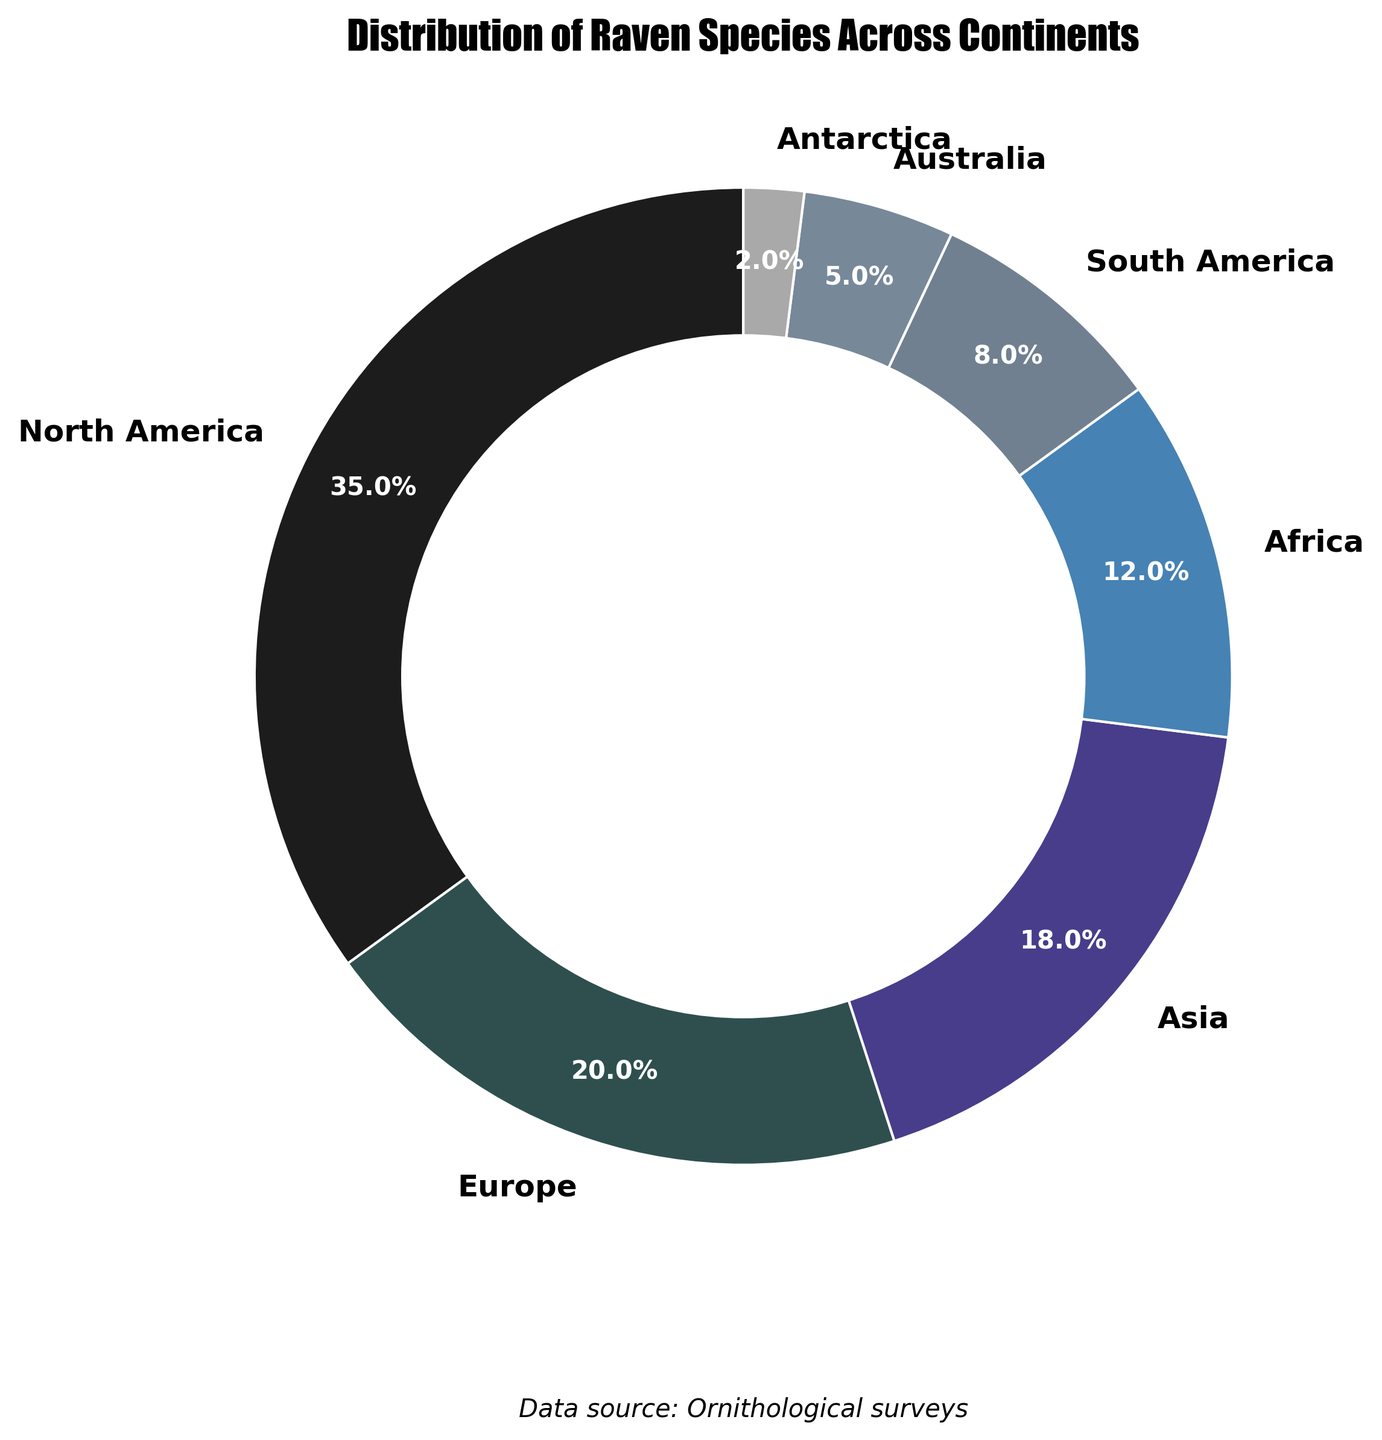Which continent has the highest percentage of raven species? The pie chart shows the percentage distribution of raven species across continents. By observing the sections, North America has the largest slice, indicating it has the highest percentage.
Answer: North America Which continents have a lower percentage of raven species than Europe? By comparing the slice sizes and percentages labeled on the pie chart, the continents with smaller percentages than Europe (20%) are Africa, South America, Australia, and Antarctica.
Answer: Africa, South America, Australia, Antarctica What is the total percentage of raven species in both Asia and Africa combined? To find the combined percentage, simply add the individual percentages of Asia (18%) and Africa (12%). 18% + 12% = 30%.
Answer: 30% How does the percentage of raven species in North America compare to the sum of South America and Antarctica? North America's percentage is 35%. Adding the percentages of South America (8%) and Antarctica (2%) gives 10%. 35% is greater than 10%.
Answer: Greater Which sections of the pie chart are represented by shades of gray, indicating lower percentages? Observing the color palette in the pie chart, shades of gray represent continents with smaller percentages. These are Australia (5%) and Antarctica (2%).
Answer: Australia, Antarctica 